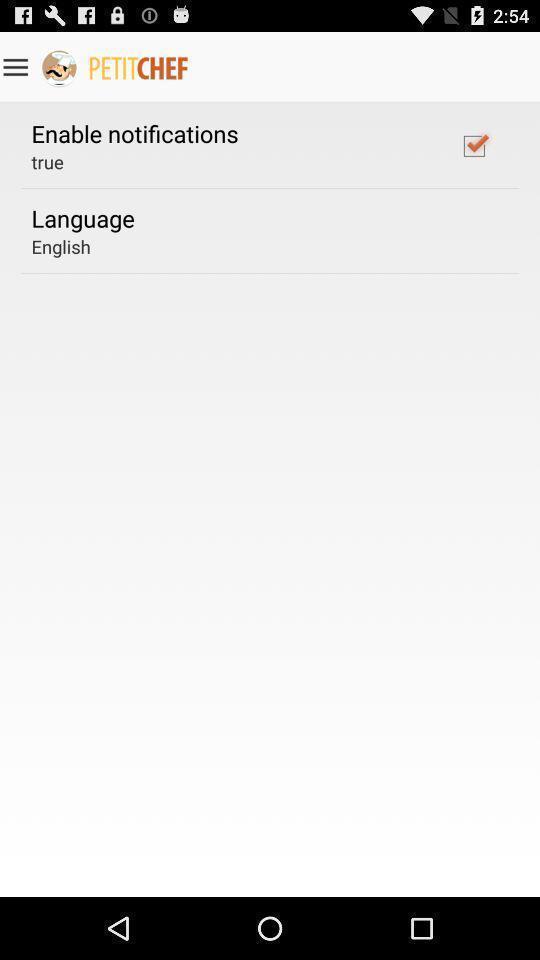Please provide a description for this image. Page displaying settings in a cooking app. 